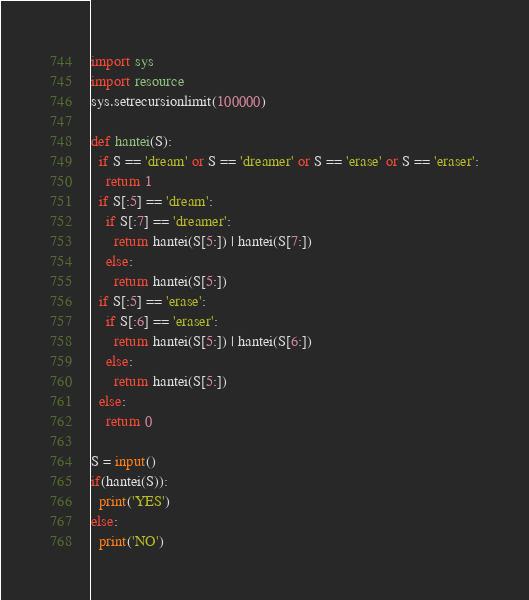<code> <loc_0><loc_0><loc_500><loc_500><_Python_>import sys
import resource
sys.setrecursionlimit(100000)

def hantei(S):
  if S == 'dream' or S == 'dreamer' or S == 'erase' or S == 'eraser':
    return 1
  if S[:5] == 'dream':
    if S[:7] == 'dreamer':
      return hantei(S[5:]) | hantei(S[7:])
    else:
      return hantei(S[5:])
  if S[:5] == 'erase':
    if S[:6] == 'eraser':
      return hantei(S[5:]) | hantei(S[6:])
    else:
      return hantei(S[5:])
  else:
    return 0

S = input()
if(hantei(S)):
  print('YES')
else:
  print('NO')</code> 